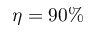Convert formula to latex. <formula><loc_0><loc_0><loc_500><loc_500>\eta = 9 0 \%</formula> 